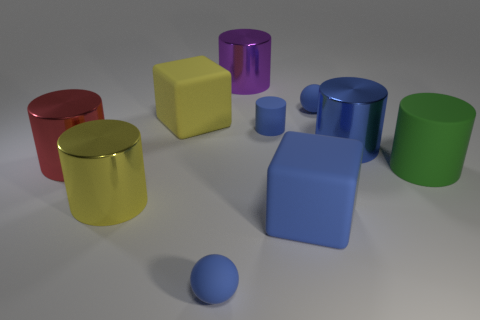There is a yellow object that is made of the same material as the large purple thing; what is its size?
Offer a terse response. Large. There is a large blue object in front of the red object; what shape is it?
Your answer should be compact. Cube. The blue matte object that is the same shape as the purple metallic thing is what size?
Keep it short and to the point. Small. What number of purple metal things are in front of the small object that is to the left of the big cylinder behind the tiny matte cylinder?
Keep it short and to the point. 0. Is the number of big yellow cylinders right of the purple cylinder the same as the number of tiny blue cylinders?
Your response must be concise. No. What number of cubes are either blue objects or big red objects?
Make the answer very short. 1. Is the number of cylinders that are on the right side of the large purple cylinder the same as the number of big metallic objects behind the large green matte thing?
Your response must be concise. Yes. The small cylinder has what color?
Your answer should be very brief. Blue. How many objects are small blue things that are behind the red thing or blue shiny balls?
Give a very brief answer. 2. Does the blue matte ball behind the big blue shiny cylinder have the same size as the metal cylinder that is right of the large purple cylinder?
Make the answer very short. No. 